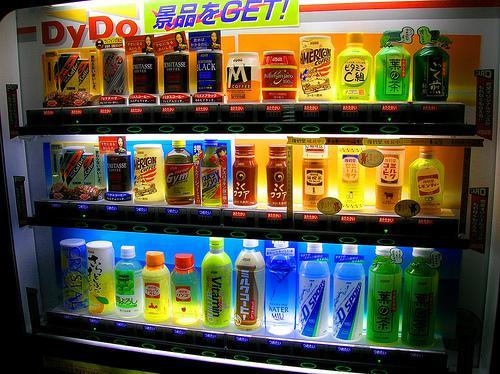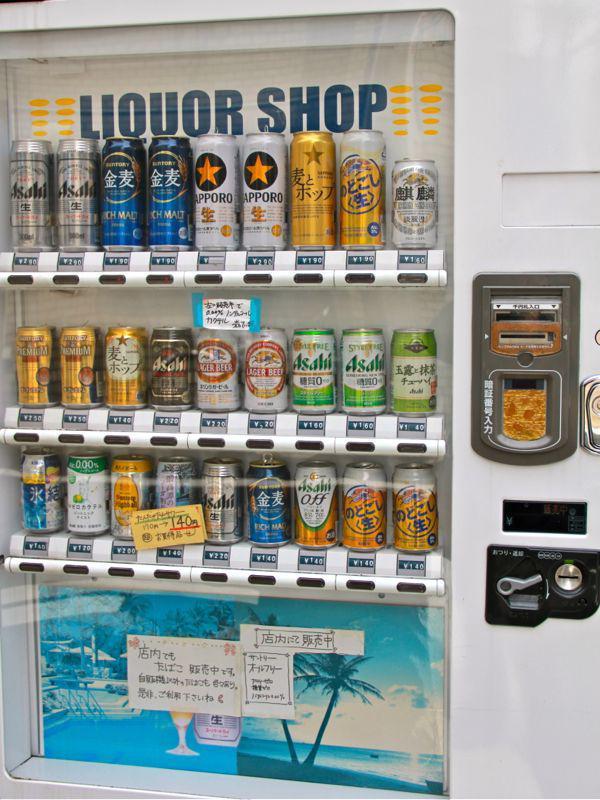The first image is the image on the left, the second image is the image on the right. Examine the images to the left and right. Is the description "Only three shelves of items are visible in the vending machine in the image on the left" accurate? Answer yes or no. Yes. The first image is the image on the left, the second image is the image on the right. Examine the images to the left and right. Is the description "A display has two identical green labeled drinks in the upper left corner." accurate? Answer yes or no. No. 